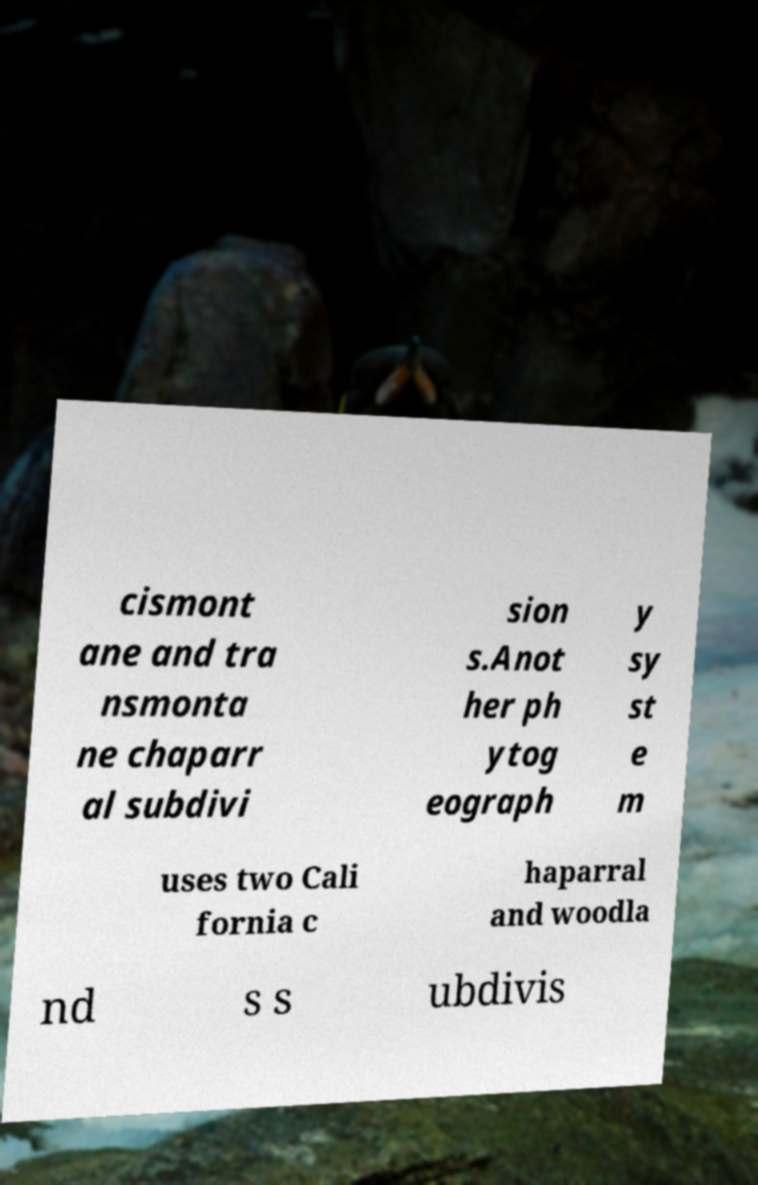Could you assist in decoding the text presented in this image and type it out clearly? cismont ane and tra nsmonta ne chaparr al subdivi sion s.Anot her ph ytog eograph y sy st e m uses two Cali fornia c haparral and woodla nd s s ubdivis 